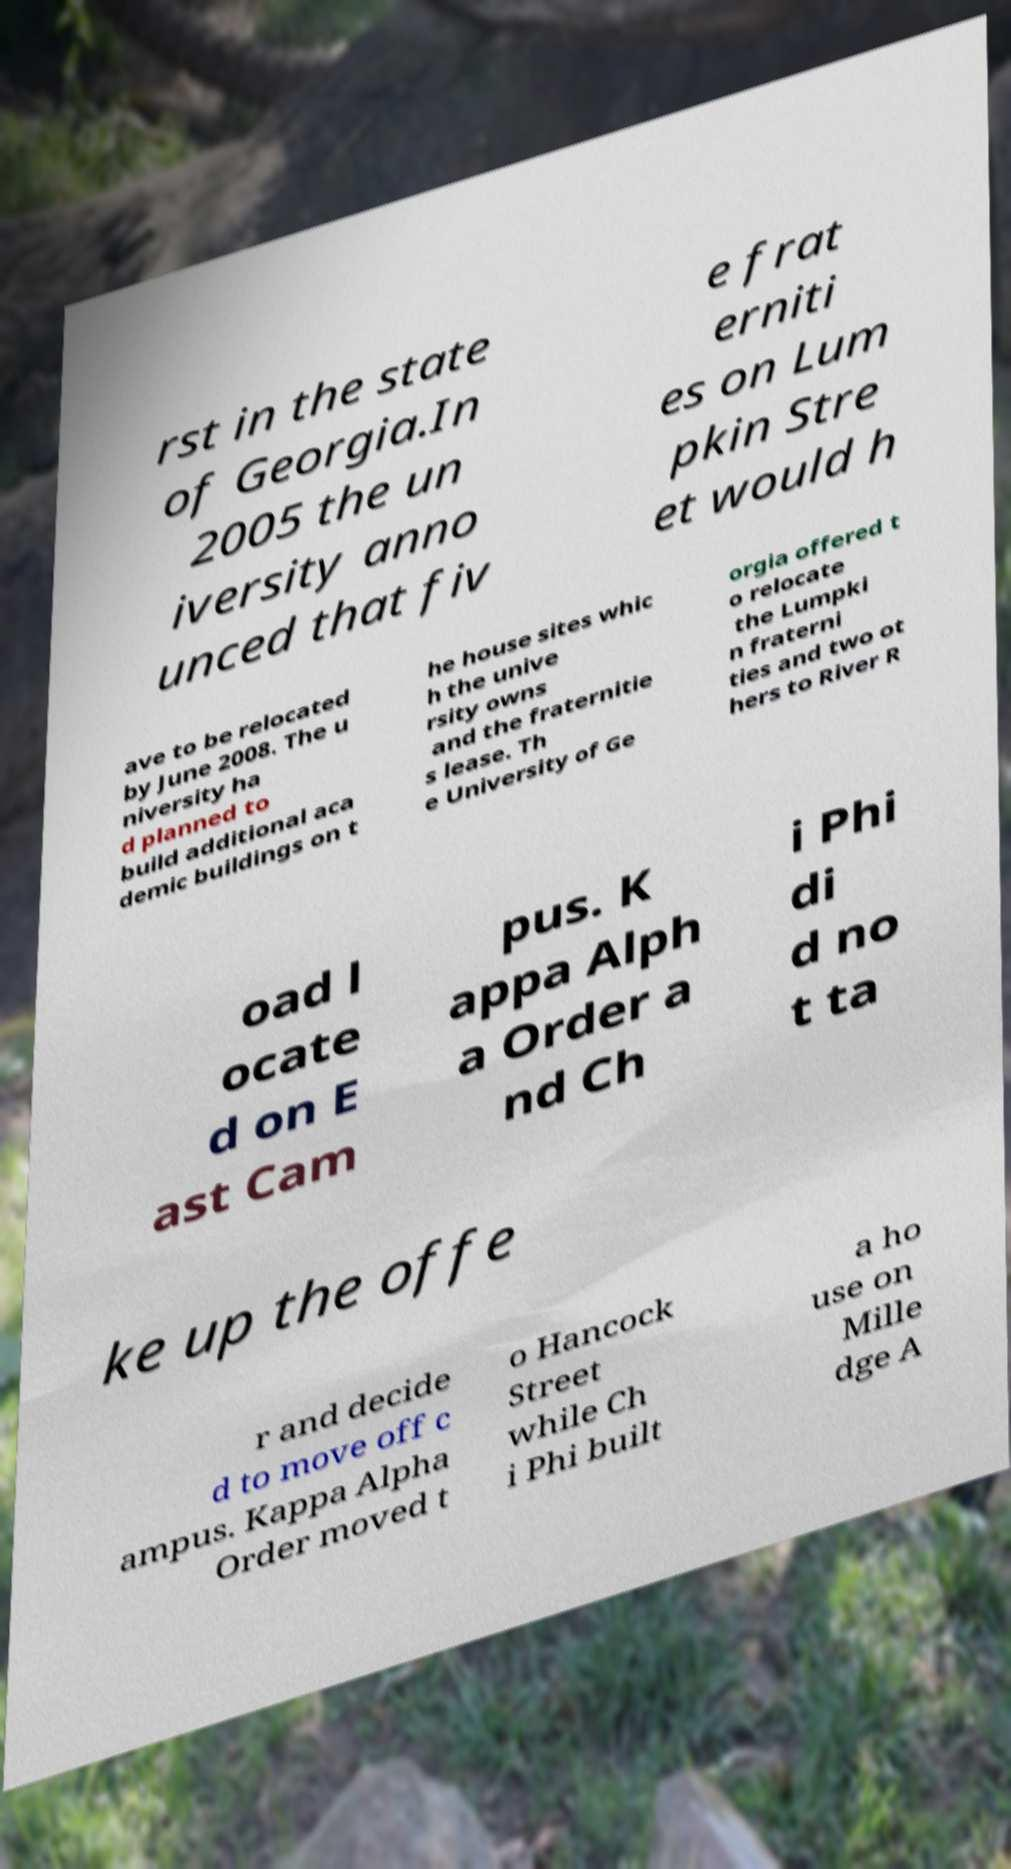There's text embedded in this image that I need extracted. Can you transcribe it verbatim? rst in the state of Georgia.In 2005 the un iversity anno unced that fiv e frat erniti es on Lum pkin Stre et would h ave to be relocated by June 2008. The u niversity ha d planned to build additional aca demic buildings on t he house sites whic h the unive rsity owns and the fraternitie s lease. Th e University of Ge orgia offered t o relocate the Lumpki n fraterni ties and two ot hers to River R oad l ocate d on E ast Cam pus. K appa Alph a Order a nd Ch i Phi di d no t ta ke up the offe r and decide d to move off c ampus. Kappa Alpha Order moved t o Hancock Street while Ch i Phi built a ho use on Mille dge A 